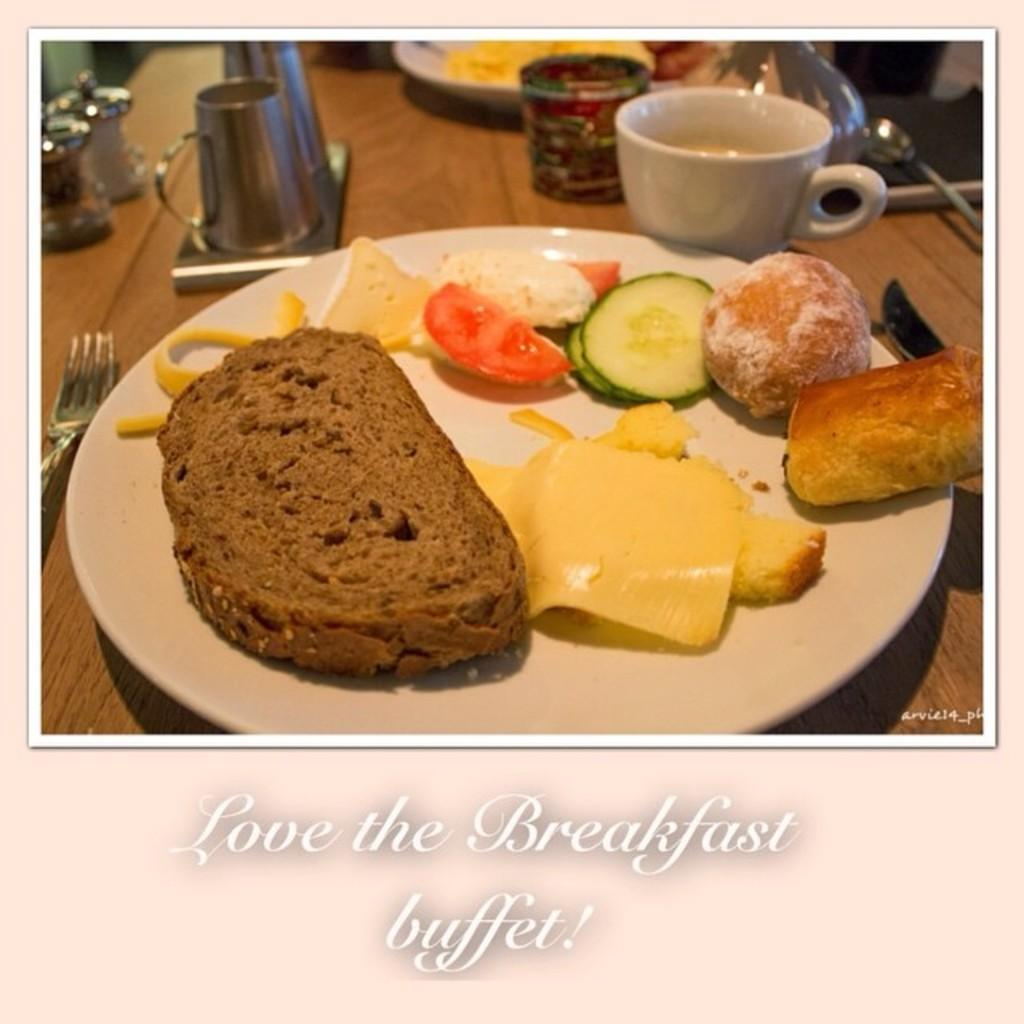What is on the plate that is visible in the image? There is a plate with cucumber and food in the image. What other dish is present in the image? There is a bowl in the image. What type of containers are visible in the image? There are jars in the image. What type of beverage container is present in the image? There is a cup in the image. What utensil is visible in the image? There is a fork in the image. What other objects can be seen on the table in the image? There are other objects on the table in the image. What is written at the bottom of the image? There is text at the bottom of the image. Where is the throne located in the image? There is no throne present in the image. Can you describe the woman sitting on the chair in the image? There is no woman present in the image. What force is being applied to the objects on the table in the image? There is no force being applied to the objects in the image; they are stationary. 